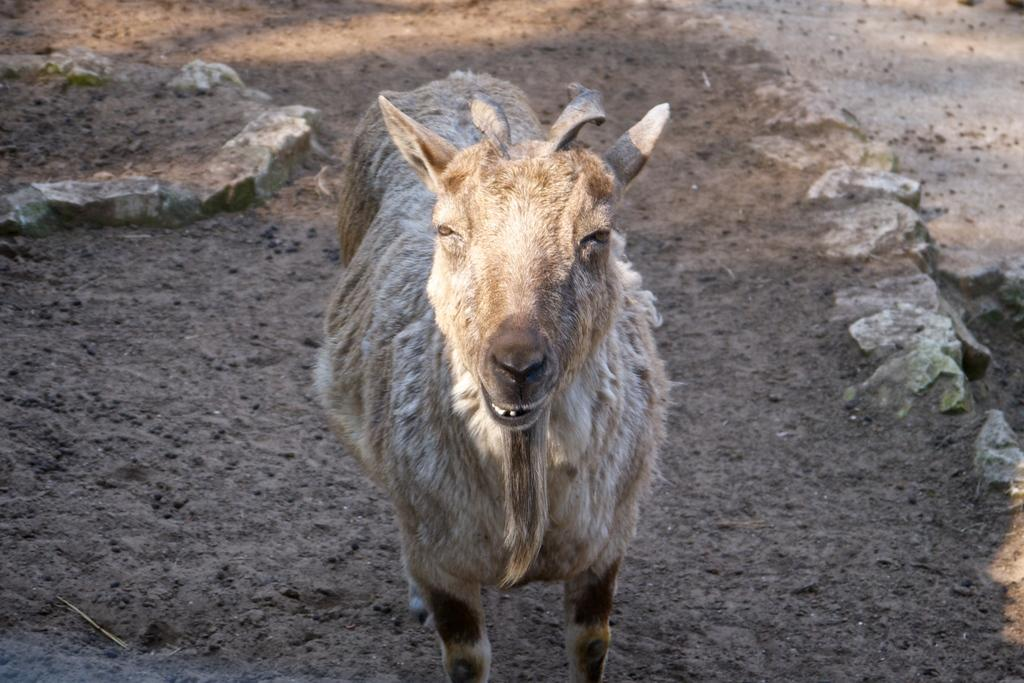What animal is present in the image? There is a goat in the image. What is the goat doing in the image? The goat is standing on the ground. What type of terrain can be seen in the image? There are stones visible in the image. Who is the creator of the frame around the goat in the image? There is no frame around the goat in the image, so there is no creator to mention. 